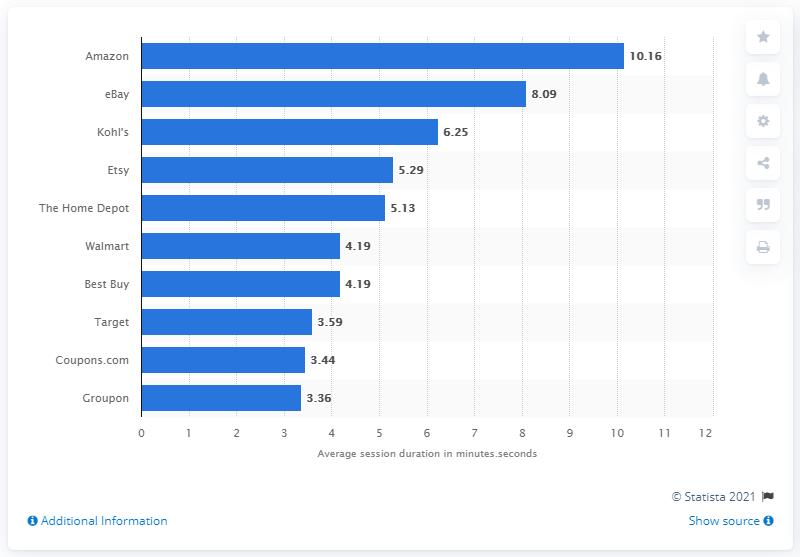Outline some significant characteristics in this image. Amazon was the top e-commerce retailer in terms of average session duration, meaning that customers spent more time browsing and shopping on its website compared to other retailers. 